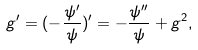<formula> <loc_0><loc_0><loc_500><loc_500>g ^ { \prime } = ( - \frac { \psi ^ { \prime } } { \psi } ) ^ { \prime } = - \frac { \psi ^ { \prime \prime } } { \psi } + g ^ { 2 } ,</formula> 